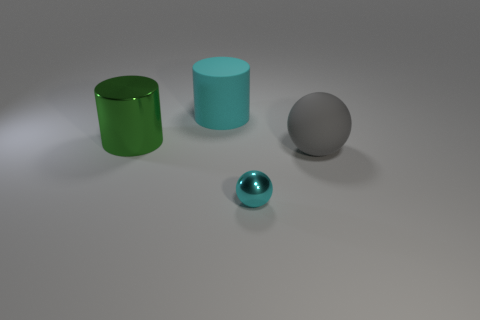How many things are green shiny cylinders or tiny rubber spheres?
Your answer should be compact. 1. How many tiny cyan balls are the same material as the big cyan object?
Provide a succinct answer. 0. Are there fewer small red cylinders than objects?
Your answer should be compact. Yes. Are the cylinder that is left of the cyan cylinder and the large cyan thing made of the same material?
Ensure brevity in your answer.  No. What number of cylinders are gray things or tiny objects?
Keep it short and to the point. 0. What is the shape of the thing that is both right of the cyan rubber cylinder and to the left of the gray sphere?
Keep it short and to the point. Sphere. What is the color of the metallic thing that is behind the cyan thing that is in front of the big cylinder to the left of the large cyan object?
Make the answer very short. Green. Are there fewer large green metal things that are to the right of the matte sphere than cyan matte objects?
Give a very brief answer. Yes. Do the rubber object that is in front of the cyan matte object and the metal object right of the large cyan cylinder have the same shape?
Keep it short and to the point. Yes. How many things are either cyan objects on the left side of the cyan metallic thing or tiny yellow matte things?
Offer a terse response. 1. 